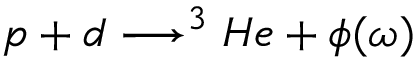Convert formula to latex. <formula><loc_0><loc_0><loc_500><loc_500>p + d \longrightarrow ^ { 3 } H e + \phi ( \omega )</formula> 